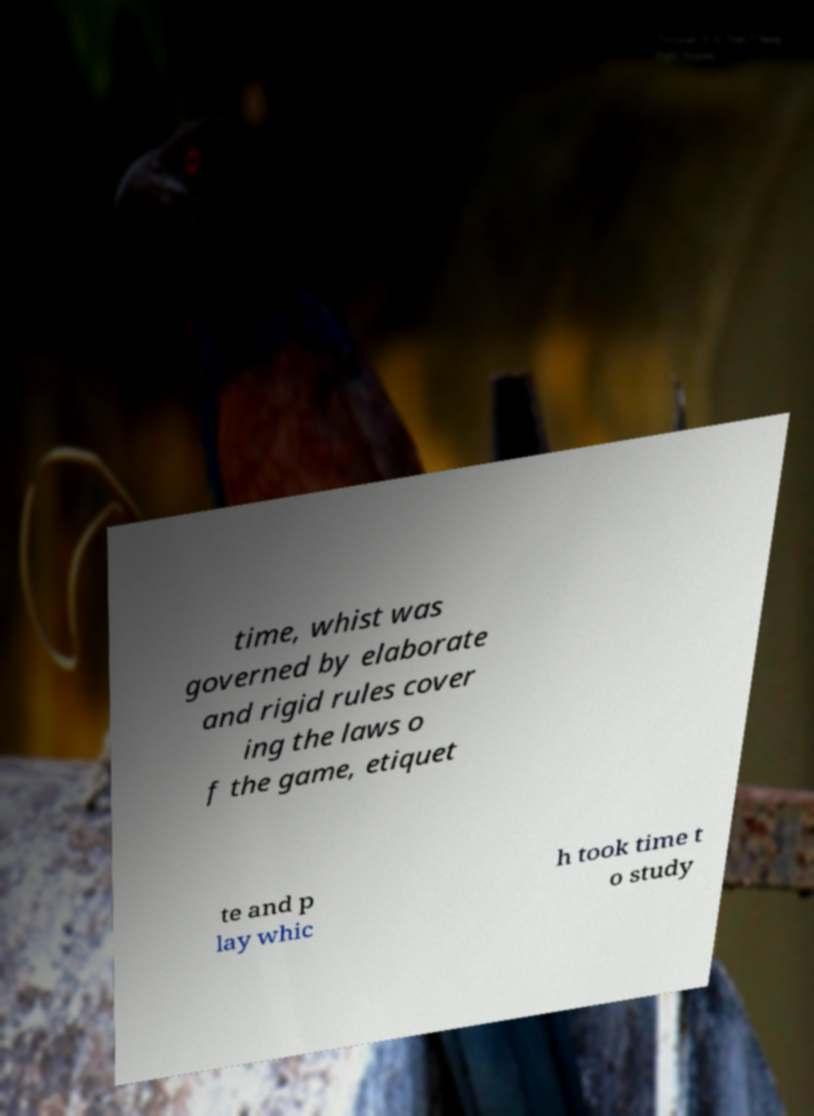What messages or text are displayed in this image? I need them in a readable, typed format. time, whist was governed by elaborate and rigid rules cover ing the laws o f the game, etiquet te and p lay whic h took time t o study 